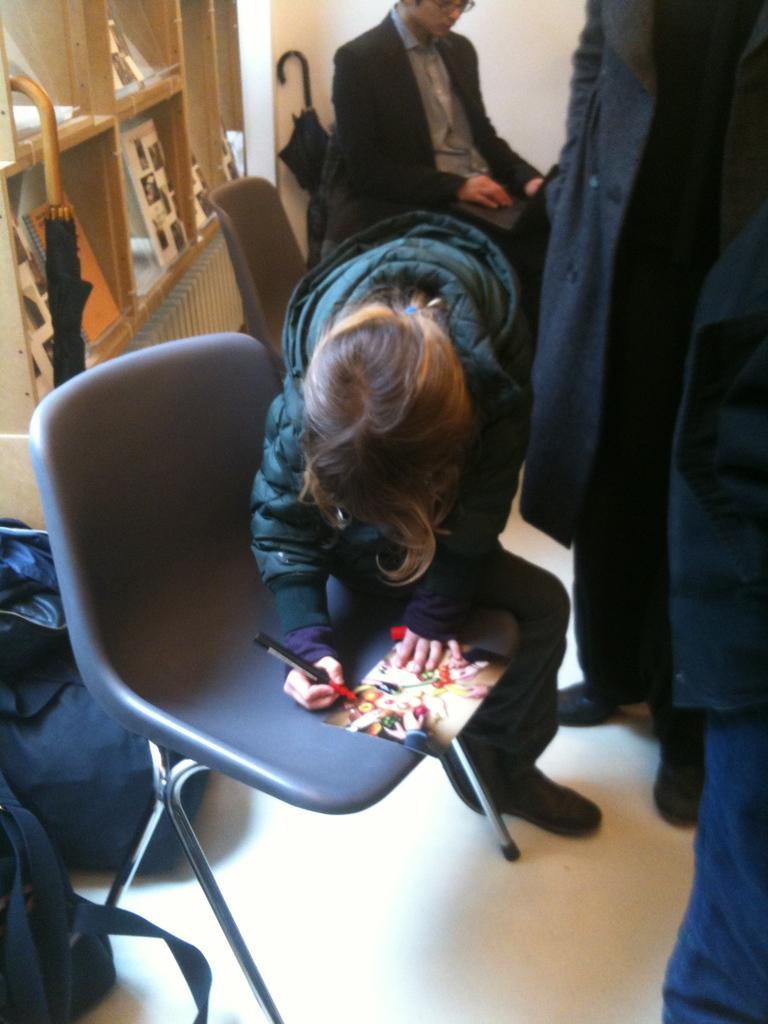Describe this image in one or two sentences. In the picture there is a room in which many people are standing and two people are sitting on a chair one person is doing something on the paper the by keeping it on the chair there are two umbrella in the room there is a shelf and on the shelf there are items there are two bags near to the chair. 